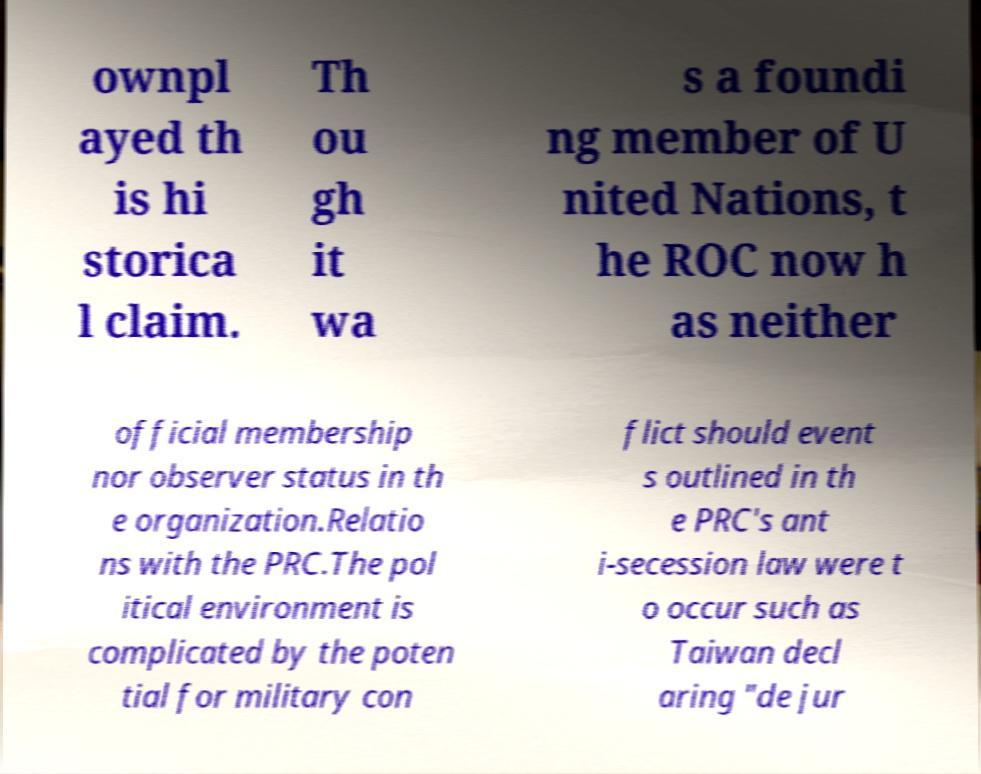There's text embedded in this image that I need extracted. Can you transcribe it verbatim? ownpl ayed th is hi storica l claim. Th ou gh it wa s a foundi ng member of U nited Nations, t he ROC now h as neither official membership nor observer status in th e organization.Relatio ns with the PRC.The pol itical environment is complicated by the poten tial for military con flict should event s outlined in th e PRC's ant i-secession law were t o occur such as Taiwan decl aring "de jur 